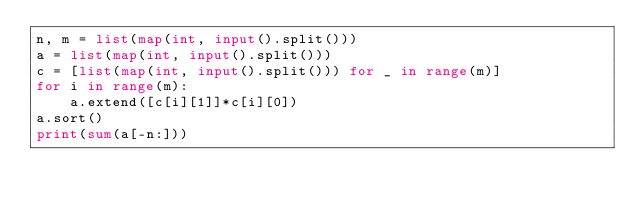<code> <loc_0><loc_0><loc_500><loc_500><_Python_>n, m = list(map(int, input().split()))
a = list(map(int, input().split()))
c = [list(map(int, input().split())) for _ in range(m)]
for i in range(m):
    a.extend([c[i][1]]*c[i][0])
a.sort()
print(sum(a[-n:]))</code> 